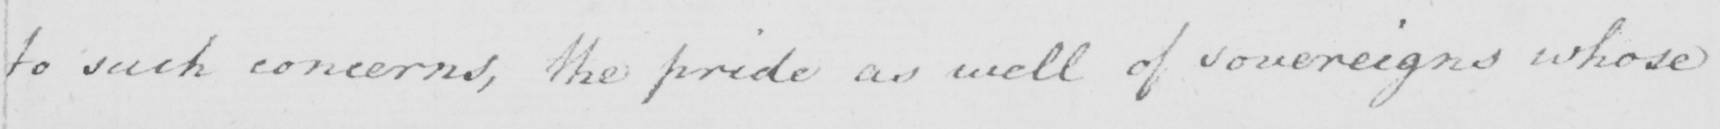Please transcribe the handwritten text in this image. to such concerns , the pride as well of sovereigns whose 